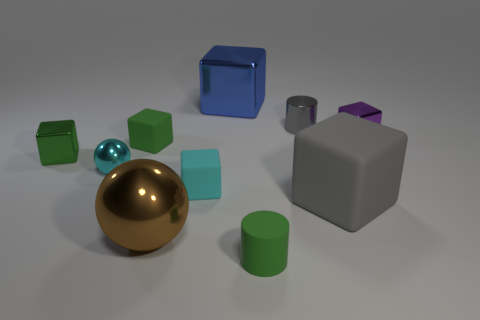Subtract all green cubes. How many cubes are left? 4 Subtract all purple balls. How many green blocks are left? 2 Subtract 1 cubes. How many cubes are left? 5 Subtract all cylinders. How many objects are left? 8 Subtract all gray blocks. How many blocks are left? 5 Subtract all brown cubes. Subtract all green cylinders. How many cubes are left? 6 Subtract all small gray shiny cylinders. Subtract all big cyan metal spheres. How many objects are left? 9 Add 1 tiny matte things. How many tiny matte things are left? 4 Add 9 green metallic cubes. How many green metallic cubes exist? 10 Subtract 1 gray cubes. How many objects are left? 9 